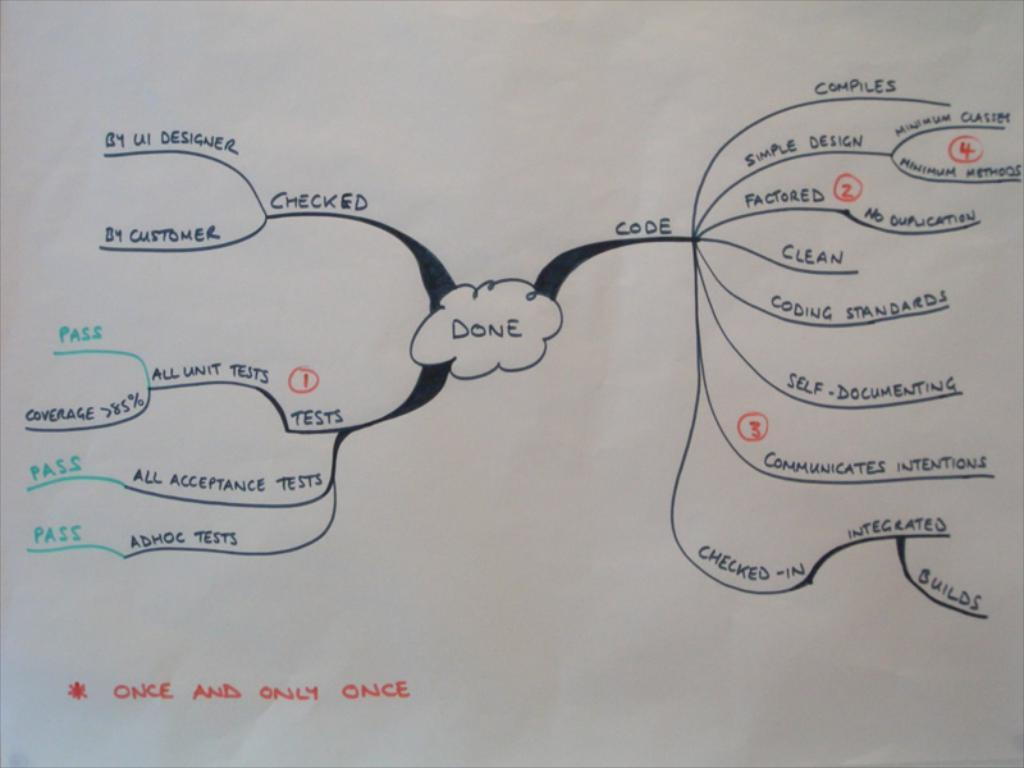Provide a one-sentence caption for the provided image. A chart is drawn out on a white piece of paper and at the bottom it says "Once and only once". 